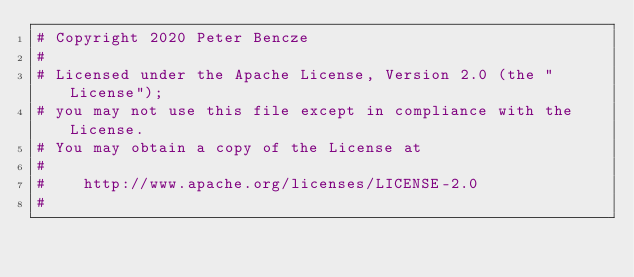Convert code to text. <code><loc_0><loc_0><loc_500><loc_500><_Python_># Copyright 2020 Peter Bencze
#
# Licensed under the Apache License, Version 2.0 (the "License");
# you may not use this file except in compliance with the License.
# You may obtain a copy of the License at
#
#    http://www.apache.org/licenses/LICENSE-2.0
#</code> 